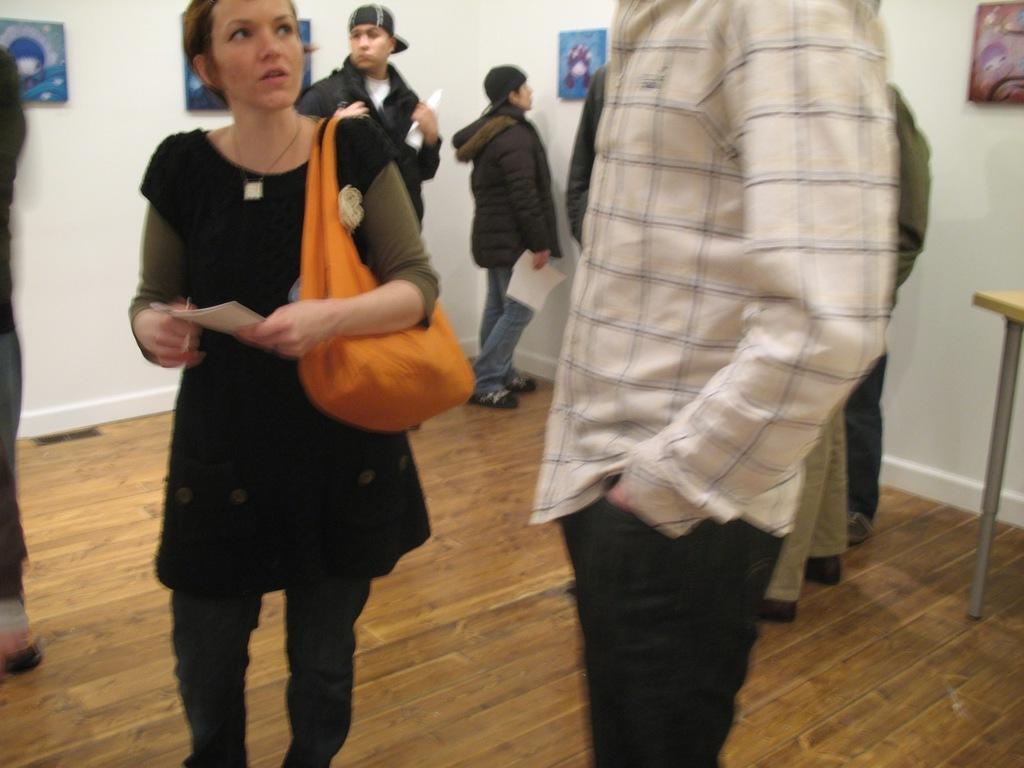In one or two sentences, can you explain what this image depicts? In this image we can see there are a few people standing on the floor, some of them are holding papers in their hands. In the background there are some photo frames are attached to the wall. 